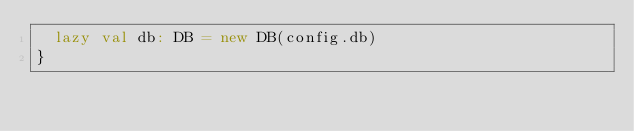Convert code to text. <code><loc_0><loc_0><loc_500><loc_500><_Scala_>  lazy val db: DB = new DB(config.db)
}
</code> 